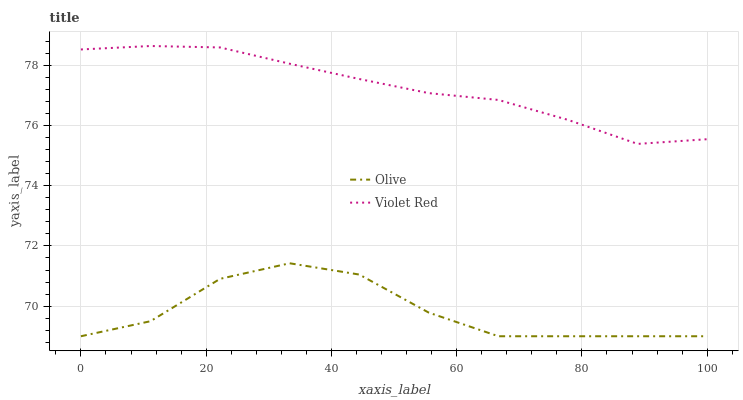Does Olive have the minimum area under the curve?
Answer yes or no. Yes. Does Violet Red have the maximum area under the curve?
Answer yes or no. Yes. Does Violet Red have the minimum area under the curve?
Answer yes or no. No. Is Violet Red the smoothest?
Answer yes or no. Yes. Is Olive the roughest?
Answer yes or no. Yes. Is Violet Red the roughest?
Answer yes or no. No. Does Olive have the lowest value?
Answer yes or no. Yes. Does Violet Red have the lowest value?
Answer yes or no. No. Does Violet Red have the highest value?
Answer yes or no. Yes. Is Olive less than Violet Red?
Answer yes or no. Yes. Is Violet Red greater than Olive?
Answer yes or no. Yes. Does Olive intersect Violet Red?
Answer yes or no. No. 